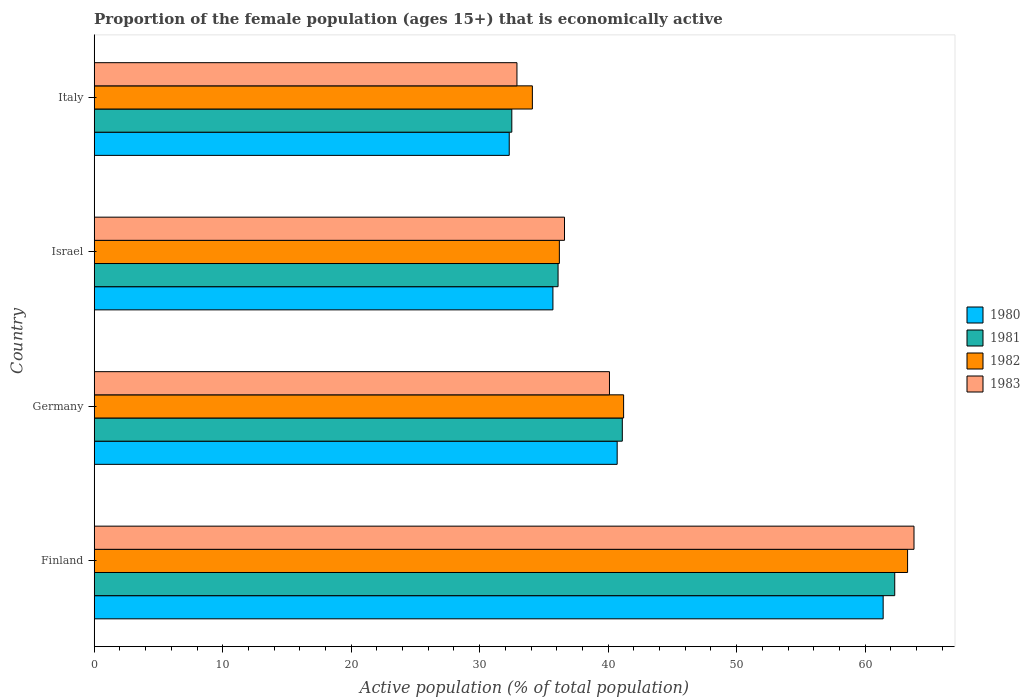How many different coloured bars are there?
Offer a terse response. 4. Are the number of bars on each tick of the Y-axis equal?
Offer a very short reply. Yes. What is the label of the 2nd group of bars from the top?
Offer a very short reply. Israel. In how many cases, is the number of bars for a given country not equal to the number of legend labels?
Offer a very short reply. 0. What is the proportion of the female population that is economically active in 1980 in Israel?
Keep it short and to the point. 35.7. Across all countries, what is the maximum proportion of the female population that is economically active in 1982?
Your answer should be very brief. 63.3. Across all countries, what is the minimum proportion of the female population that is economically active in 1980?
Your answer should be very brief. 32.3. In which country was the proportion of the female population that is economically active in 1983 minimum?
Keep it short and to the point. Italy. What is the total proportion of the female population that is economically active in 1982 in the graph?
Provide a short and direct response. 174.8. What is the difference between the proportion of the female population that is economically active in 1981 in Israel and that in Italy?
Your answer should be compact. 3.6. What is the average proportion of the female population that is economically active in 1980 per country?
Offer a very short reply. 42.53. What is the difference between the proportion of the female population that is economically active in 1980 and proportion of the female population that is economically active in 1981 in Finland?
Ensure brevity in your answer.  -0.9. What is the ratio of the proportion of the female population that is economically active in 1980 in Finland to that in Germany?
Your answer should be compact. 1.51. Is the proportion of the female population that is economically active in 1980 in Germany less than that in Italy?
Offer a very short reply. No. Is the difference between the proportion of the female population that is economically active in 1980 in Finland and Germany greater than the difference between the proportion of the female population that is economically active in 1981 in Finland and Germany?
Your response must be concise. No. What is the difference between the highest and the second highest proportion of the female population that is economically active in 1980?
Provide a short and direct response. 20.7. What is the difference between the highest and the lowest proportion of the female population that is economically active in 1982?
Ensure brevity in your answer.  29.2. How many bars are there?
Provide a succinct answer. 16. Are all the bars in the graph horizontal?
Keep it short and to the point. Yes. Are the values on the major ticks of X-axis written in scientific E-notation?
Your response must be concise. No. How are the legend labels stacked?
Provide a short and direct response. Vertical. What is the title of the graph?
Give a very brief answer. Proportion of the female population (ages 15+) that is economically active. What is the label or title of the X-axis?
Make the answer very short. Active population (% of total population). What is the Active population (% of total population) of 1980 in Finland?
Your answer should be very brief. 61.4. What is the Active population (% of total population) of 1981 in Finland?
Your answer should be compact. 62.3. What is the Active population (% of total population) of 1982 in Finland?
Ensure brevity in your answer.  63.3. What is the Active population (% of total population) in 1983 in Finland?
Your answer should be very brief. 63.8. What is the Active population (% of total population) in 1980 in Germany?
Your response must be concise. 40.7. What is the Active population (% of total population) in 1981 in Germany?
Keep it short and to the point. 41.1. What is the Active population (% of total population) of 1982 in Germany?
Provide a short and direct response. 41.2. What is the Active population (% of total population) of 1983 in Germany?
Provide a short and direct response. 40.1. What is the Active population (% of total population) of 1980 in Israel?
Keep it short and to the point. 35.7. What is the Active population (% of total population) in 1981 in Israel?
Provide a succinct answer. 36.1. What is the Active population (% of total population) of 1982 in Israel?
Your answer should be very brief. 36.2. What is the Active population (% of total population) in 1983 in Israel?
Make the answer very short. 36.6. What is the Active population (% of total population) of 1980 in Italy?
Provide a short and direct response. 32.3. What is the Active population (% of total population) in 1981 in Italy?
Provide a succinct answer. 32.5. What is the Active population (% of total population) of 1982 in Italy?
Your answer should be very brief. 34.1. What is the Active population (% of total population) of 1983 in Italy?
Keep it short and to the point. 32.9. Across all countries, what is the maximum Active population (% of total population) of 1980?
Your response must be concise. 61.4. Across all countries, what is the maximum Active population (% of total population) of 1981?
Make the answer very short. 62.3. Across all countries, what is the maximum Active population (% of total population) of 1982?
Offer a terse response. 63.3. Across all countries, what is the maximum Active population (% of total population) of 1983?
Provide a short and direct response. 63.8. Across all countries, what is the minimum Active population (% of total population) of 1980?
Keep it short and to the point. 32.3. Across all countries, what is the minimum Active population (% of total population) of 1981?
Your response must be concise. 32.5. Across all countries, what is the minimum Active population (% of total population) in 1982?
Offer a terse response. 34.1. Across all countries, what is the minimum Active population (% of total population) in 1983?
Provide a succinct answer. 32.9. What is the total Active population (% of total population) in 1980 in the graph?
Your answer should be compact. 170.1. What is the total Active population (% of total population) in 1981 in the graph?
Provide a succinct answer. 172. What is the total Active population (% of total population) of 1982 in the graph?
Offer a terse response. 174.8. What is the total Active population (% of total population) of 1983 in the graph?
Ensure brevity in your answer.  173.4. What is the difference between the Active population (% of total population) in 1980 in Finland and that in Germany?
Ensure brevity in your answer.  20.7. What is the difference between the Active population (% of total population) in 1981 in Finland and that in Germany?
Make the answer very short. 21.2. What is the difference between the Active population (% of total population) of 1982 in Finland and that in Germany?
Provide a short and direct response. 22.1. What is the difference between the Active population (% of total population) of 1983 in Finland and that in Germany?
Provide a short and direct response. 23.7. What is the difference between the Active population (% of total population) in 1980 in Finland and that in Israel?
Ensure brevity in your answer.  25.7. What is the difference between the Active population (% of total population) in 1981 in Finland and that in Israel?
Make the answer very short. 26.2. What is the difference between the Active population (% of total population) in 1982 in Finland and that in Israel?
Provide a succinct answer. 27.1. What is the difference between the Active population (% of total population) in 1983 in Finland and that in Israel?
Your answer should be compact. 27.2. What is the difference between the Active population (% of total population) of 1980 in Finland and that in Italy?
Offer a very short reply. 29.1. What is the difference between the Active population (% of total population) of 1981 in Finland and that in Italy?
Provide a succinct answer. 29.8. What is the difference between the Active population (% of total population) of 1982 in Finland and that in Italy?
Offer a terse response. 29.2. What is the difference between the Active population (% of total population) in 1983 in Finland and that in Italy?
Keep it short and to the point. 30.9. What is the difference between the Active population (% of total population) in 1980 in Germany and that in Israel?
Your answer should be compact. 5. What is the difference between the Active population (% of total population) in 1982 in Germany and that in Israel?
Provide a succinct answer. 5. What is the difference between the Active population (% of total population) of 1981 in Germany and that in Italy?
Your answer should be very brief. 8.6. What is the difference between the Active population (% of total population) in 1980 in Israel and that in Italy?
Give a very brief answer. 3.4. What is the difference between the Active population (% of total population) in 1983 in Israel and that in Italy?
Give a very brief answer. 3.7. What is the difference between the Active population (% of total population) of 1980 in Finland and the Active population (% of total population) of 1981 in Germany?
Your response must be concise. 20.3. What is the difference between the Active population (% of total population) of 1980 in Finland and the Active population (% of total population) of 1982 in Germany?
Your response must be concise. 20.2. What is the difference between the Active population (% of total population) in 1980 in Finland and the Active population (% of total population) in 1983 in Germany?
Provide a short and direct response. 21.3. What is the difference between the Active population (% of total population) of 1981 in Finland and the Active population (% of total population) of 1982 in Germany?
Provide a succinct answer. 21.1. What is the difference between the Active population (% of total population) of 1981 in Finland and the Active population (% of total population) of 1983 in Germany?
Your response must be concise. 22.2. What is the difference between the Active population (% of total population) of 1982 in Finland and the Active population (% of total population) of 1983 in Germany?
Provide a succinct answer. 23.2. What is the difference between the Active population (% of total population) of 1980 in Finland and the Active population (% of total population) of 1981 in Israel?
Provide a short and direct response. 25.3. What is the difference between the Active population (% of total population) in 1980 in Finland and the Active population (% of total population) in 1982 in Israel?
Give a very brief answer. 25.2. What is the difference between the Active population (% of total population) in 1980 in Finland and the Active population (% of total population) in 1983 in Israel?
Give a very brief answer. 24.8. What is the difference between the Active population (% of total population) of 1981 in Finland and the Active population (% of total population) of 1982 in Israel?
Your response must be concise. 26.1. What is the difference between the Active population (% of total population) in 1981 in Finland and the Active population (% of total population) in 1983 in Israel?
Offer a very short reply. 25.7. What is the difference between the Active population (% of total population) in 1982 in Finland and the Active population (% of total population) in 1983 in Israel?
Give a very brief answer. 26.7. What is the difference between the Active population (% of total population) in 1980 in Finland and the Active population (% of total population) in 1981 in Italy?
Offer a very short reply. 28.9. What is the difference between the Active population (% of total population) of 1980 in Finland and the Active population (% of total population) of 1982 in Italy?
Keep it short and to the point. 27.3. What is the difference between the Active population (% of total population) of 1980 in Finland and the Active population (% of total population) of 1983 in Italy?
Your response must be concise. 28.5. What is the difference between the Active population (% of total population) in 1981 in Finland and the Active population (% of total population) in 1982 in Italy?
Offer a terse response. 28.2. What is the difference between the Active population (% of total population) in 1981 in Finland and the Active population (% of total population) in 1983 in Italy?
Offer a very short reply. 29.4. What is the difference between the Active population (% of total population) of 1982 in Finland and the Active population (% of total population) of 1983 in Italy?
Ensure brevity in your answer.  30.4. What is the difference between the Active population (% of total population) in 1980 in Germany and the Active population (% of total population) in 1981 in Israel?
Offer a terse response. 4.6. What is the difference between the Active population (% of total population) in 1980 in Germany and the Active population (% of total population) in 1983 in Israel?
Provide a succinct answer. 4.1. What is the difference between the Active population (% of total population) in 1981 in Germany and the Active population (% of total population) in 1983 in Israel?
Offer a terse response. 4.5. What is the difference between the Active population (% of total population) in 1980 in Germany and the Active population (% of total population) in 1981 in Italy?
Provide a succinct answer. 8.2. What is the difference between the Active population (% of total population) of 1981 in Germany and the Active population (% of total population) of 1982 in Italy?
Keep it short and to the point. 7. What is the difference between the Active population (% of total population) in 1982 in Germany and the Active population (% of total population) in 1983 in Italy?
Your answer should be very brief. 8.3. What is the difference between the Active population (% of total population) of 1980 in Israel and the Active population (% of total population) of 1983 in Italy?
Offer a very short reply. 2.8. What is the average Active population (% of total population) of 1980 per country?
Keep it short and to the point. 42.52. What is the average Active population (% of total population) in 1982 per country?
Your answer should be very brief. 43.7. What is the average Active population (% of total population) in 1983 per country?
Provide a short and direct response. 43.35. What is the difference between the Active population (% of total population) of 1980 and Active population (% of total population) of 1981 in Finland?
Give a very brief answer. -0.9. What is the difference between the Active population (% of total population) of 1980 and Active population (% of total population) of 1983 in Finland?
Provide a short and direct response. -2.4. What is the difference between the Active population (% of total population) of 1981 and Active population (% of total population) of 1983 in Finland?
Your answer should be very brief. -1.5. What is the difference between the Active population (% of total population) of 1980 and Active population (% of total population) of 1981 in Germany?
Ensure brevity in your answer.  -0.4. What is the difference between the Active population (% of total population) in 1981 and Active population (% of total population) in 1983 in Germany?
Provide a short and direct response. 1. What is the difference between the Active population (% of total population) of 1982 and Active population (% of total population) of 1983 in Germany?
Ensure brevity in your answer.  1.1. What is the difference between the Active population (% of total population) of 1980 and Active population (% of total population) of 1981 in Israel?
Offer a terse response. -0.4. What is the difference between the Active population (% of total population) of 1980 and Active population (% of total population) of 1983 in Israel?
Give a very brief answer. -0.9. What is the difference between the Active population (% of total population) of 1981 and Active population (% of total population) of 1982 in Israel?
Provide a succinct answer. -0.1. What is the difference between the Active population (% of total population) in 1981 and Active population (% of total population) in 1983 in Israel?
Your answer should be compact. -0.5. What is the difference between the Active population (% of total population) of 1982 and Active population (% of total population) of 1983 in Israel?
Your answer should be very brief. -0.4. What is the difference between the Active population (% of total population) of 1980 and Active population (% of total population) of 1981 in Italy?
Offer a terse response. -0.2. What is the difference between the Active population (% of total population) of 1980 and Active population (% of total population) of 1982 in Italy?
Provide a succinct answer. -1.8. What is the difference between the Active population (% of total population) of 1980 and Active population (% of total population) of 1983 in Italy?
Offer a terse response. -0.6. What is the difference between the Active population (% of total population) in 1981 and Active population (% of total population) in 1982 in Italy?
Keep it short and to the point. -1.6. What is the difference between the Active population (% of total population) of 1981 and Active population (% of total population) of 1983 in Italy?
Provide a succinct answer. -0.4. What is the difference between the Active population (% of total population) in 1982 and Active population (% of total population) in 1983 in Italy?
Offer a very short reply. 1.2. What is the ratio of the Active population (% of total population) in 1980 in Finland to that in Germany?
Offer a very short reply. 1.51. What is the ratio of the Active population (% of total population) in 1981 in Finland to that in Germany?
Your answer should be compact. 1.52. What is the ratio of the Active population (% of total population) in 1982 in Finland to that in Germany?
Ensure brevity in your answer.  1.54. What is the ratio of the Active population (% of total population) in 1983 in Finland to that in Germany?
Your answer should be compact. 1.59. What is the ratio of the Active population (% of total population) of 1980 in Finland to that in Israel?
Your answer should be very brief. 1.72. What is the ratio of the Active population (% of total population) in 1981 in Finland to that in Israel?
Offer a terse response. 1.73. What is the ratio of the Active population (% of total population) in 1982 in Finland to that in Israel?
Your answer should be very brief. 1.75. What is the ratio of the Active population (% of total population) of 1983 in Finland to that in Israel?
Make the answer very short. 1.74. What is the ratio of the Active population (% of total population) of 1980 in Finland to that in Italy?
Offer a terse response. 1.9. What is the ratio of the Active population (% of total population) of 1981 in Finland to that in Italy?
Your answer should be compact. 1.92. What is the ratio of the Active population (% of total population) in 1982 in Finland to that in Italy?
Provide a succinct answer. 1.86. What is the ratio of the Active population (% of total population) of 1983 in Finland to that in Italy?
Offer a terse response. 1.94. What is the ratio of the Active population (% of total population) of 1980 in Germany to that in Israel?
Offer a terse response. 1.14. What is the ratio of the Active population (% of total population) in 1981 in Germany to that in Israel?
Ensure brevity in your answer.  1.14. What is the ratio of the Active population (% of total population) of 1982 in Germany to that in Israel?
Your answer should be very brief. 1.14. What is the ratio of the Active population (% of total population) of 1983 in Germany to that in Israel?
Keep it short and to the point. 1.1. What is the ratio of the Active population (% of total population) in 1980 in Germany to that in Italy?
Your answer should be compact. 1.26. What is the ratio of the Active population (% of total population) of 1981 in Germany to that in Italy?
Keep it short and to the point. 1.26. What is the ratio of the Active population (% of total population) in 1982 in Germany to that in Italy?
Provide a succinct answer. 1.21. What is the ratio of the Active population (% of total population) in 1983 in Germany to that in Italy?
Provide a short and direct response. 1.22. What is the ratio of the Active population (% of total population) in 1980 in Israel to that in Italy?
Your answer should be compact. 1.11. What is the ratio of the Active population (% of total population) of 1981 in Israel to that in Italy?
Provide a short and direct response. 1.11. What is the ratio of the Active population (% of total population) in 1982 in Israel to that in Italy?
Offer a very short reply. 1.06. What is the ratio of the Active population (% of total population) of 1983 in Israel to that in Italy?
Keep it short and to the point. 1.11. What is the difference between the highest and the second highest Active population (% of total population) in 1980?
Keep it short and to the point. 20.7. What is the difference between the highest and the second highest Active population (% of total population) of 1981?
Keep it short and to the point. 21.2. What is the difference between the highest and the second highest Active population (% of total population) in 1982?
Make the answer very short. 22.1. What is the difference between the highest and the second highest Active population (% of total population) in 1983?
Your response must be concise. 23.7. What is the difference between the highest and the lowest Active population (% of total population) in 1980?
Your answer should be compact. 29.1. What is the difference between the highest and the lowest Active population (% of total population) in 1981?
Keep it short and to the point. 29.8. What is the difference between the highest and the lowest Active population (% of total population) in 1982?
Give a very brief answer. 29.2. What is the difference between the highest and the lowest Active population (% of total population) in 1983?
Your answer should be very brief. 30.9. 